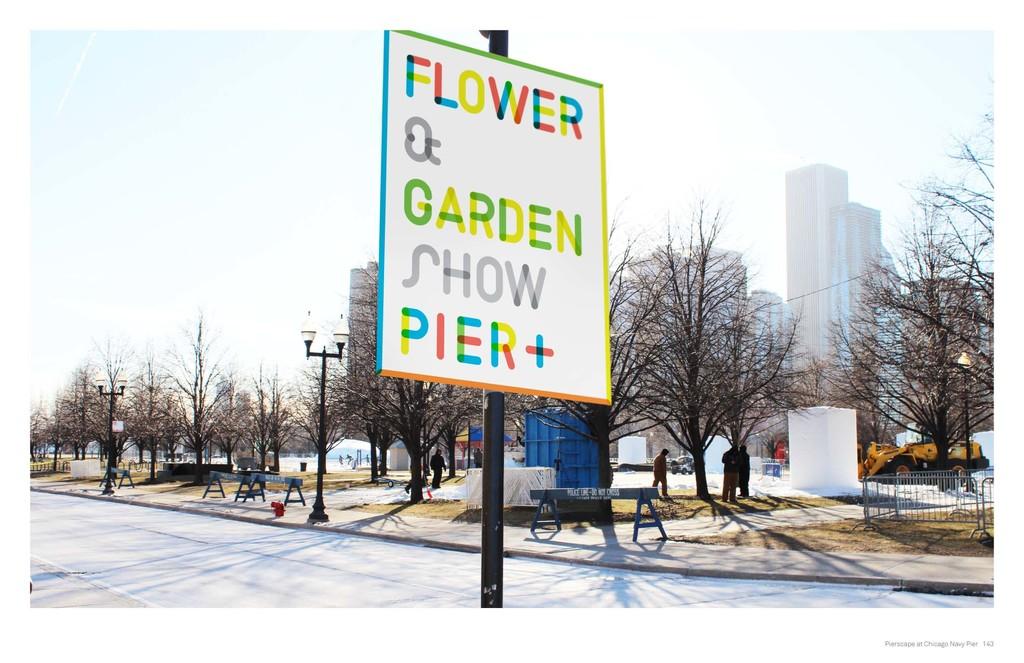What kind of show is being advertised?
Give a very brief answer. Flower & garden show. Where is the flower and garden show being held?
Make the answer very short. Pier+. 